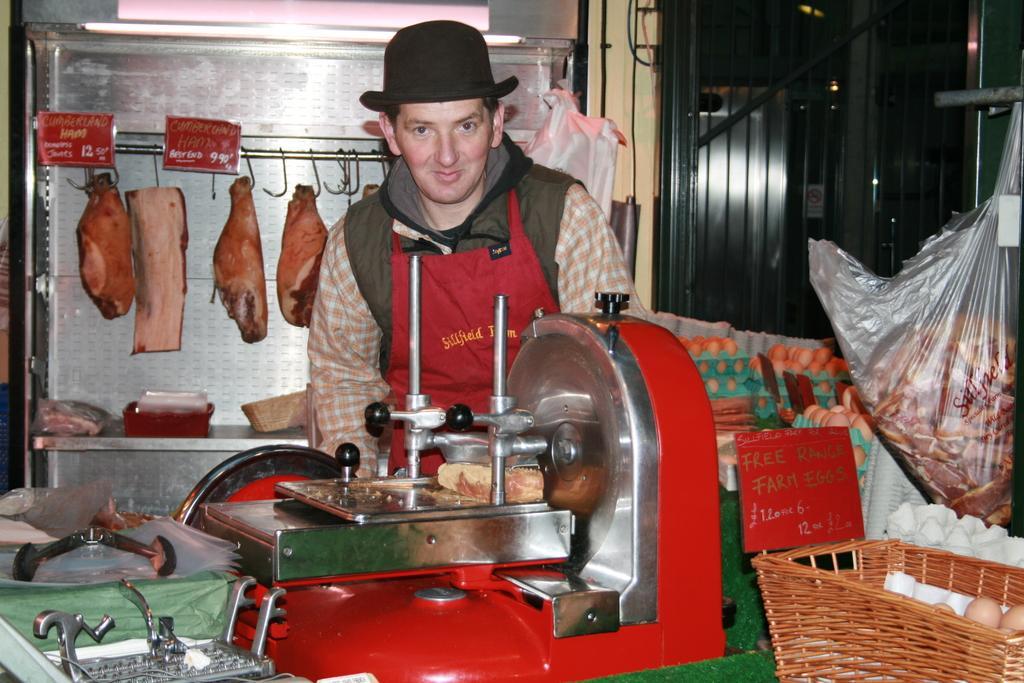Could you give a brief overview of what you see in this image? In this picture we can see a person in the middle, there is a machine in the front, on the right side there are some trays, a basket and a plastic bag, we can see eggs in these trays and basket, in the background we can see meat and two boards, this person is wearing a cap. 